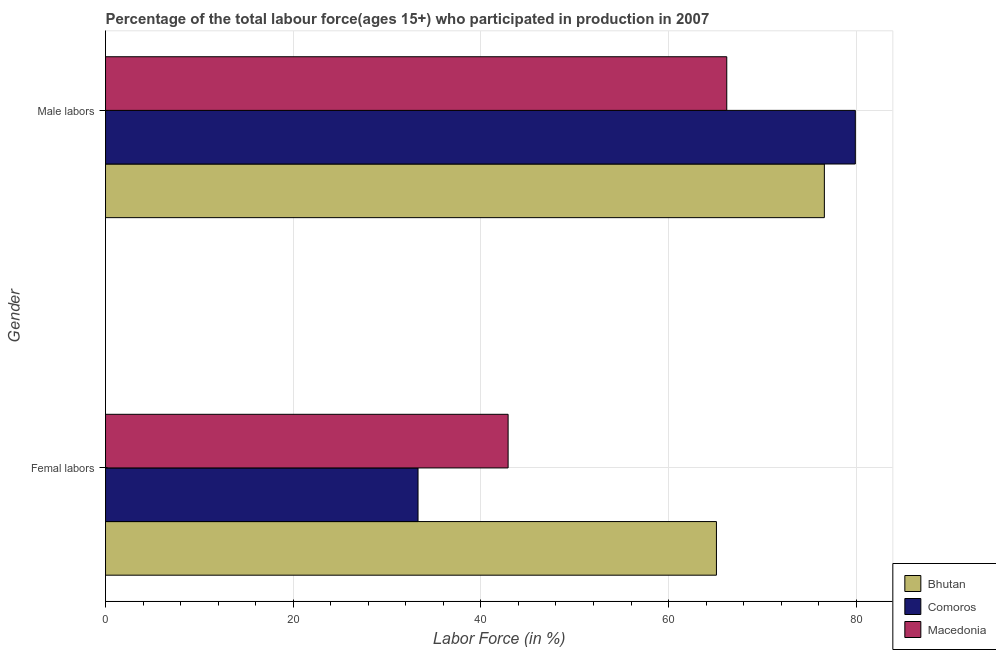Are the number of bars per tick equal to the number of legend labels?
Provide a succinct answer. Yes. Are the number of bars on each tick of the Y-axis equal?
Provide a succinct answer. Yes. What is the label of the 1st group of bars from the top?
Give a very brief answer. Male labors. What is the percentage of male labour force in Bhutan?
Offer a very short reply. 76.6. Across all countries, what is the maximum percentage of female labor force?
Make the answer very short. 65.1. Across all countries, what is the minimum percentage of male labour force?
Make the answer very short. 66.2. In which country was the percentage of male labour force maximum?
Give a very brief answer. Comoros. In which country was the percentage of male labour force minimum?
Keep it short and to the point. Macedonia. What is the total percentage of male labour force in the graph?
Provide a short and direct response. 222.7. What is the difference between the percentage of male labour force in Macedonia and that in Bhutan?
Ensure brevity in your answer.  -10.4. What is the difference between the percentage of female labor force in Comoros and the percentage of male labour force in Bhutan?
Ensure brevity in your answer.  -43.3. What is the average percentage of female labor force per country?
Keep it short and to the point. 47.1. What is the difference between the percentage of male labour force and percentage of female labor force in Bhutan?
Provide a succinct answer. 11.5. What is the ratio of the percentage of male labour force in Bhutan to that in Macedonia?
Your answer should be compact. 1.16. Is the percentage of male labour force in Comoros less than that in Macedonia?
Offer a terse response. No. In how many countries, is the percentage of male labour force greater than the average percentage of male labour force taken over all countries?
Offer a very short reply. 2. What does the 1st bar from the top in Femal labors represents?
Your answer should be very brief. Macedonia. What does the 3rd bar from the bottom in Male labors represents?
Offer a terse response. Macedonia. How many bars are there?
Offer a very short reply. 6. Are all the bars in the graph horizontal?
Your answer should be very brief. Yes. What is the difference between two consecutive major ticks on the X-axis?
Your answer should be very brief. 20. Are the values on the major ticks of X-axis written in scientific E-notation?
Offer a very short reply. No. How are the legend labels stacked?
Make the answer very short. Vertical. What is the title of the graph?
Provide a succinct answer. Percentage of the total labour force(ages 15+) who participated in production in 2007. Does "Libya" appear as one of the legend labels in the graph?
Your answer should be compact. No. What is the label or title of the X-axis?
Offer a very short reply. Labor Force (in %). What is the Labor Force (in %) in Bhutan in Femal labors?
Offer a terse response. 65.1. What is the Labor Force (in %) of Comoros in Femal labors?
Provide a short and direct response. 33.3. What is the Labor Force (in %) in Macedonia in Femal labors?
Your answer should be compact. 42.9. What is the Labor Force (in %) in Bhutan in Male labors?
Offer a terse response. 76.6. What is the Labor Force (in %) in Comoros in Male labors?
Make the answer very short. 79.9. What is the Labor Force (in %) in Macedonia in Male labors?
Your answer should be very brief. 66.2. Across all Gender, what is the maximum Labor Force (in %) in Bhutan?
Provide a succinct answer. 76.6. Across all Gender, what is the maximum Labor Force (in %) of Comoros?
Give a very brief answer. 79.9. Across all Gender, what is the maximum Labor Force (in %) of Macedonia?
Your answer should be compact. 66.2. Across all Gender, what is the minimum Labor Force (in %) of Bhutan?
Your response must be concise. 65.1. Across all Gender, what is the minimum Labor Force (in %) in Comoros?
Make the answer very short. 33.3. Across all Gender, what is the minimum Labor Force (in %) of Macedonia?
Offer a very short reply. 42.9. What is the total Labor Force (in %) of Bhutan in the graph?
Make the answer very short. 141.7. What is the total Labor Force (in %) of Comoros in the graph?
Give a very brief answer. 113.2. What is the total Labor Force (in %) in Macedonia in the graph?
Your response must be concise. 109.1. What is the difference between the Labor Force (in %) of Comoros in Femal labors and that in Male labors?
Your answer should be very brief. -46.6. What is the difference between the Labor Force (in %) of Macedonia in Femal labors and that in Male labors?
Your answer should be compact. -23.3. What is the difference between the Labor Force (in %) of Bhutan in Femal labors and the Labor Force (in %) of Comoros in Male labors?
Ensure brevity in your answer.  -14.8. What is the difference between the Labor Force (in %) of Comoros in Femal labors and the Labor Force (in %) of Macedonia in Male labors?
Provide a short and direct response. -32.9. What is the average Labor Force (in %) of Bhutan per Gender?
Keep it short and to the point. 70.85. What is the average Labor Force (in %) of Comoros per Gender?
Your response must be concise. 56.6. What is the average Labor Force (in %) of Macedonia per Gender?
Provide a short and direct response. 54.55. What is the difference between the Labor Force (in %) in Bhutan and Labor Force (in %) in Comoros in Femal labors?
Provide a succinct answer. 31.8. What is the difference between the Labor Force (in %) in Bhutan and Labor Force (in %) in Macedonia in Femal labors?
Make the answer very short. 22.2. What is the difference between the Labor Force (in %) of Bhutan and Labor Force (in %) of Comoros in Male labors?
Your answer should be compact. -3.3. What is the ratio of the Labor Force (in %) of Bhutan in Femal labors to that in Male labors?
Give a very brief answer. 0.85. What is the ratio of the Labor Force (in %) of Comoros in Femal labors to that in Male labors?
Provide a short and direct response. 0.42. What is the ratio of the Labor Force (in %) in Macedonia in Femal labors to that in Male labors?
Keep it short and to the point. 0.65. What is the difference between the highest and the second highest Labor Force (in %) in Comoros?
Your answer should be very brief. 46.6. What is the difference between the highest and the second highest Labor Force (in %) in Macedonia?
Your response must be concise. 23.3. What is the difference between the highest and the lowest Labor Force (in %) of Comoros?
Your answer should be very brief. 46.6. What is the difference between the highest and the lowest Labor Force (in %) of Macedonia?
Offer a very short reply. 23.3. 